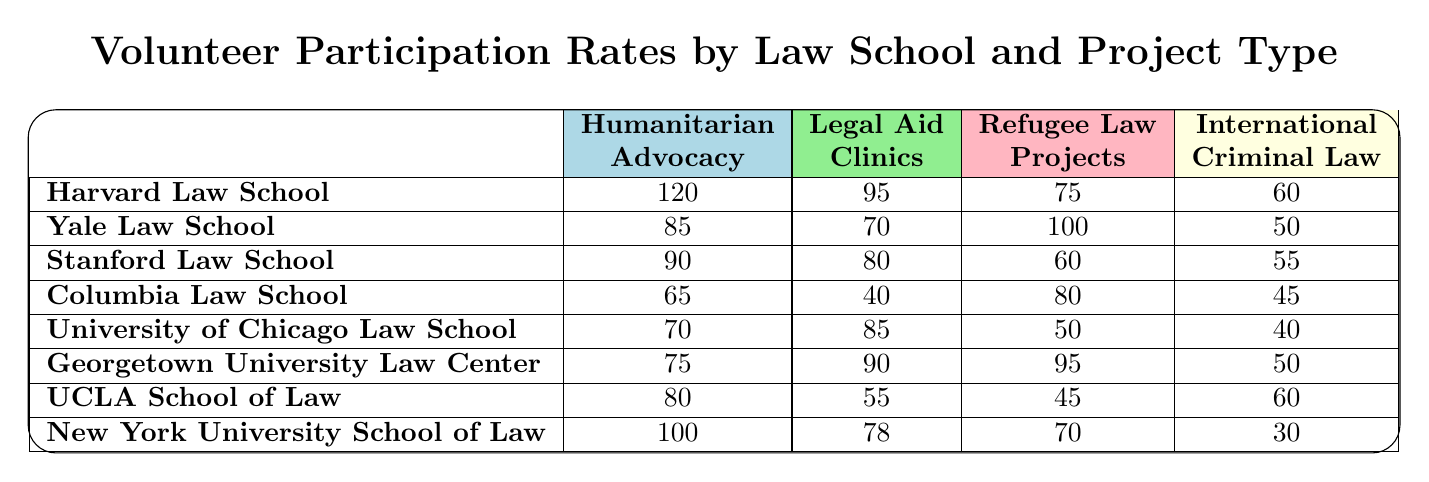What is the highest volunteer participation rate in the Humanitarian Advocacy category? The highest value in the Humanitarian Advocacy column is 120, which corresponds to Harvard Law School.
Answer: 120 Which law school has the lowest participation rate in International Criminal Law? The lowest value in the International Criminal Law column is 30, which corresponds to New York University School of Law.
Answer: 30 Is there a law school that has an equal participation rate in both Legal Aid Clinics and Refugee Law Projects? No law school has the same number of volunteers for both categories. The closest is Georgetown University Law Center with 90 and 95, respectively.
Answer: No What is the average participation rate for the Legal Aid Clinics across all law schools? The sum of participation rates for Legal Aid Clinics is (95 + 70 + 80 + 40 + 85 + 90 + 55 + 78) =  690 and there are 8 law schools, so the average is 690/8 = 86.25.
Answer: 86.25 Which law school has the highest volunteer participation in Refugee Law Projects, and what is the participation rate? The highest value in the Refugee Law Projects column is 100, which corresponds to Yale Law School.
Answer: Yale Law School, 100 What is the total volunteer participation from Georgetown University Law Center in all categories? The total for Georgetown University Law Center is (75 + 90 + 95 + 50) = 310. Therefore, the total participation is 310 across all project types.
Answer: 310 Which two law schools have a combined total of exactly 170 participants in Humanitarian Advocacy? Harvard Law School (120) and Yale Law School (85) have a combined total of 205, while Stanford Law School (90) and UCLA School of Law (80) have a combined total of 170.
Answer: Stanford Law School and UCLA School of Law Is the participation rate in Humanitarian Advocacy for Columbia Law School more than that of the University of Chicago Law School? Columbia Law School has 65 and the University of Chicago Law School has 70 in Humanitarian Advocacy, which means University of Chicago Law School has a higher rate.
Answer: No What is the difference between the highest and lowest participation rates in Legal Aid Clinics? The highest participation rate is 95 from Harvard Law School and the lowest is 40 from Columbia Law School. The difference is 95 - 40 = 55.
Answer: 55 Which law school has the highest total participation across all project types, and what is the total participation? Harvard Law School has the highest total participation of (120 + 95 + 75 + 60) = 350.
Answer: 350 